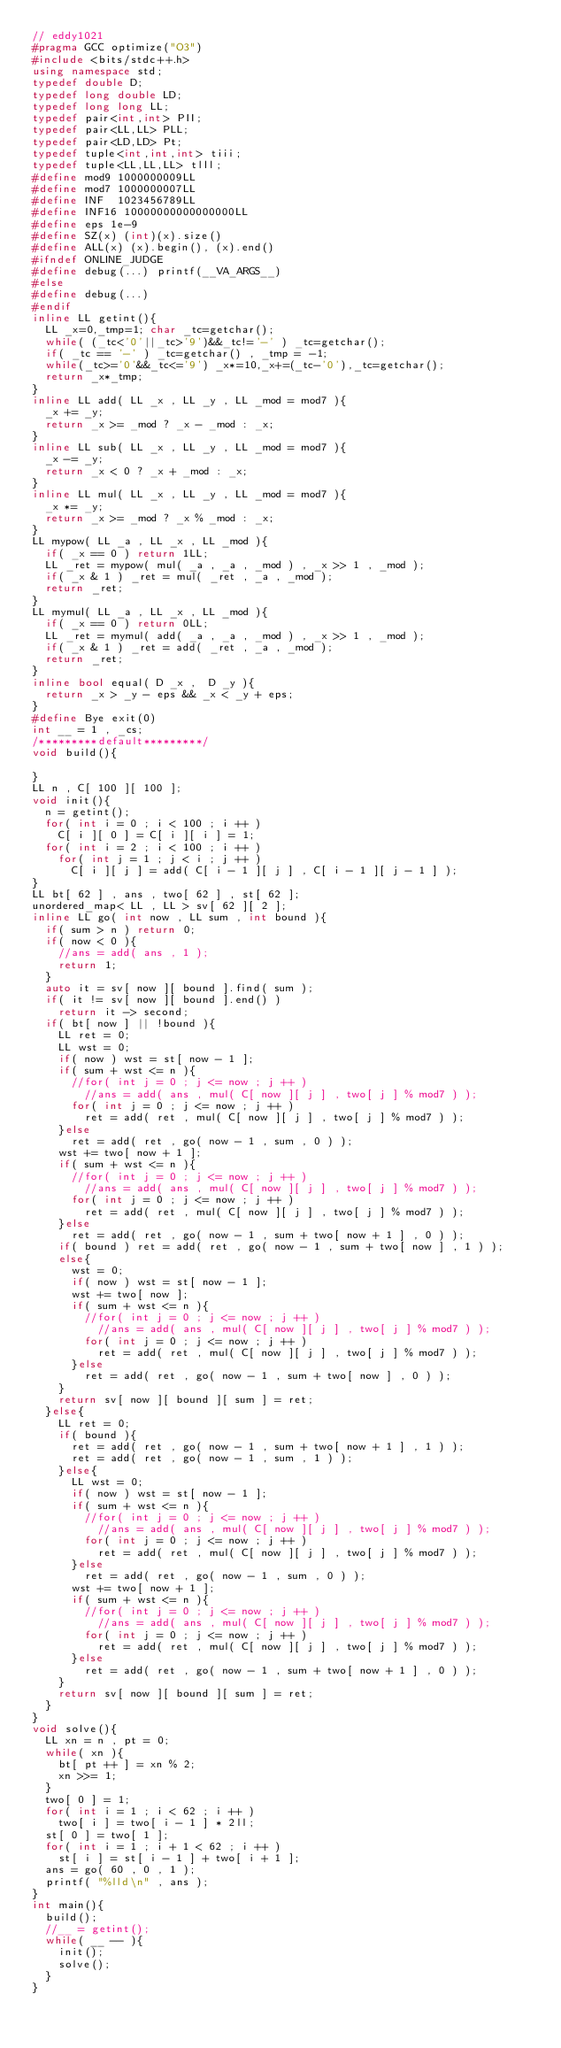<code> <loc_0><loc_0><loc_500><loc_500><_C++_>// eddy1021
#pragma GCC optimize("O3")
#include <bits/stdc++.h>
using namespace std;
typedef double D;
typedef long double LD;
typedef long long LL;
typedef pair<int,int> PII;
typedef pair<LL,LL> PLL;
typedef pair<LD,LD> Pt;
typedef tuple<int,int,int> tiii;
typedef tuple<LL,LL,LL> tlll;
#define mod9 1000000009LL
#define mod7 1000000007LL
#define INF  1023456789LL
#define INF16 10000000000000000LL
#define eps 1e-9
#define SZ(x) (int)(x).size()
#define ALL(x) (x).begin(), (x).end()
#ifndef ONLINE_JUDGE
#define debug(...) printf(__VA_ARGS__)
#else 
#define debug(...)
#endif
inline LL getint(){
  LL _x=0,_tmp=1; char _tc=getchar();    
  while( (_tc<'0'||_tc>'9')&&_tc!='-' ) _tc=getchar();
  if( _tc == '-' ) _tc=getchar() , _tmp = -1;
  while(_tc>='0'&&_tc<='9') _x*=10,_x+=(_tc-'0'),_tc=getchar();
  return _x*_tmp;
}
inline LL add( LL _x , LL _y , LL _mod = mod7 ){
  _x += _y;
  return _x >= _mod ? _x - _mod : _x;
}
inline LL sub( LL _x , LL _y , LL _mod = mod7 ){
  _x -= _y;
  return _x < 0 ? _x + _mod : _x;
}
inline LL mul( LL _x , LL _y , LL _mod = mod7 ){
  _x *= _y;
  return _x >= _mod ? _x % _mod : _x;
}
LL mypow( LL _a , LL _x , LL _mod ){
  if( _x == 0 ) return 1LL;
  LL _ret = mypow( mul( _a , _a , _mod ) , _x >> 1 , _mod );
  if( _x & 1 ) _ret = mul( _ret , _a , _mod );
  return _ret;
}
LL mymul( LL _a , LL _x , LL _mod ){
  if( _x == 0 ) return 0LL;
  LL _ret = mymul( add( _a , _a , _mod ) , _x >> 1 , _mod );
  if( _x & 1 ) _ret = add( _ret , _a , _mod );
  return _ret;
}
inline bool equal( D _x ,  D _y ){
  return _x > _y - eps && _x < _y + eps;
}
#define Bye exit(0)
int __ = 1 , _cs;
/*********default*********/
void build(){

}
LL n , C[ 100 ][ 100 ];
void init(){
  n = getint();
  for( int i = 0 ; i < 100 ; i ++ )
    C[ i ][ 0 ] = C[ i ][ i ] = 1;
  for( int i = 2 ; i < 100 ; i ++ )
    for( int j = 1 ; j < i ; j ++ )
      C[ i ][ j ] = add( C[ i - 1 ][ j ] , C[ i - 1 ][ j - 1 ] );
}
LL bt[ 62 ] , ans , two[ 62 ] , st[ 62 ];
unordered_map< LL , LL > sv[ 62 ][ 2 ];
inline LL go( int now , LL sum , int bound ){
  if( sum > n ) return 0;
  if( now < 0 ){
    //ans = add( ans , 1 );
    return 1;
  }
  auto it = sv[ now ][ bound ].find( sum );
  if( it != sv[ now ][ bound ].end() )
    return it -> second;
  if( bt[ now ] || !bound ){
    LL ret = 0;
    LL wst = 0;
    if( now ) wst = st[ now - 1 ];
    if( sum + wst <= n ){
      //for( int j = 0 ; j <= now ; j ++ )
        //ans = add( ans , mul( C[ now ][ j ] , two[ j ] % mod7 ) );
      for( int j = 0 ; j <= now ; j ++ )
        ret = add( ret , mul( C[ now ][ j ] , two[ j ] % mod7 ) );
    }else
      ret = add( ret , go( now - 1 , sum , 0 ) );
    wst += two[ now + 1 ];
    if( sum + wst <= n ){
      //for( int j = 0 ; j <= now ; j ++ )
        //ans = add( ans , mul( C[ now ][ j ] , two[ j ] % mod7 ) );
      for( int j = 0 ; j <= now ; j ++ )
        ret = add( ret , mul( C[ now ][ j ] , two[ j ] % mod7 ) );
    }else
      ret = add( ret , go( now - 1 , sum + two[ now + 1 ] , 0 ) );
    if( bound ) ret = add( ret , go( now - 1 , sum + two[ now ] , 1 ) );
    else{
      wst = 0;
      if( now ) wst = st[ now - 1 ];
      wst += two[ now ];
      if( sum + wst <= n ){
        //for( int j = 0 ; j <= now ; j ++ )
          //ans = add( ans , mul( C[ now ][ j ] , two[ j ] % mod7 ) );
        for( int j = 0 ; j <= now ; j ++ )
          ret = add( ret , mul( C[ now ][ j ] , two[ j ] % mod7 ) );
      }else
        ret = add( ret , go( now - 1 , sum + two[ now ] , 0 ) );
    }
    return sv[ now ][ bound ][ sum ] = ret;
  }else{
    LL ret = 0;
    if( bound ){
      ret = add( ret , go( now - 1 , sum + two[ now + 1 ] , 1 ) );
      ret = add( ret , go( now - 1 , sum , 1 ) );
    }else{
      LL wst = 0;
      if( now ) wst = st[ now - 1 ];
      if( sum + wst <= n ){
        //for( int j = 0 ; j <= now ; j ++ )
          //ans = add( ans , mul( C[ now ][ j ] , two[ j ] % mod7 ) );
        for( int j = 0 ; j <= now ; j ++ )
          ret = add( ret , mul( C[ now ][ j ] , two[ j ] % mod7 ) );
      }else
        ret = add( ret , go( now - 1 , sum , 0 ) );
      wst += two[ now + 1 ];
      if( sum + wst <= n ){
        //for( int j = 0 ; j <= now ; j ++ )
          //ans = add( ans , mul( C[ now ][ j ] , two[ j ] % mod7 ) );
        for( int j = 0 ; j <= now ; j ++ )
          ret = add( ret , mul( C[ now ][ j ] , two[ j ] % mod7 ) );
      }else
        ret = add( ret , go( now - 1 , sum + two[ now + 1 ] , 0 ) );
    }
    return sv[ now ][ bound ][ sum ] = ret;
  }
}
void solve(){
  LL xn = n , pt = 0;
  while( xn ){
    bt[ pt ++ ] = xn % 2;
    xn >>= 1;
  }
  two[ 0 ] = 1;
  for( int i = 1 ; i < 62 ; i ++ )
    two[ i ] = two[ i - 1 ] * 2ll;
  st[ 0 ] = two[ 1 ];
  for( int i = 1 ; i + 1 < 62 ; i ++ )
    st[ i ] = st[ i - 1 ] + two[ i + 1 ];
  ans = go( 60 , 0 , 1 );
  printf( "%lld\n" , ans );
}
int main(){
  build();
  //__ = getint();
  while( __ -- ){
    init();
    solve();
  }
}
</code> 